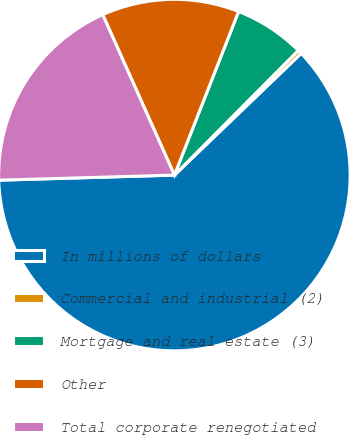Convert chart. <chart><loc_0><loc_0><loc_500><loc_500><pie_chart><fcel>In millions of dollars<fcel>Commercial and industrial (2)<fcel>Mortgage and real estate (3)<fcel>Other<fcel>Total corporate renegotiated<nl><fcel>61.72%<fcel>0.37%<fcel>6.5%<fcel>12.64%<fcel>18.77%<nl></chart> 